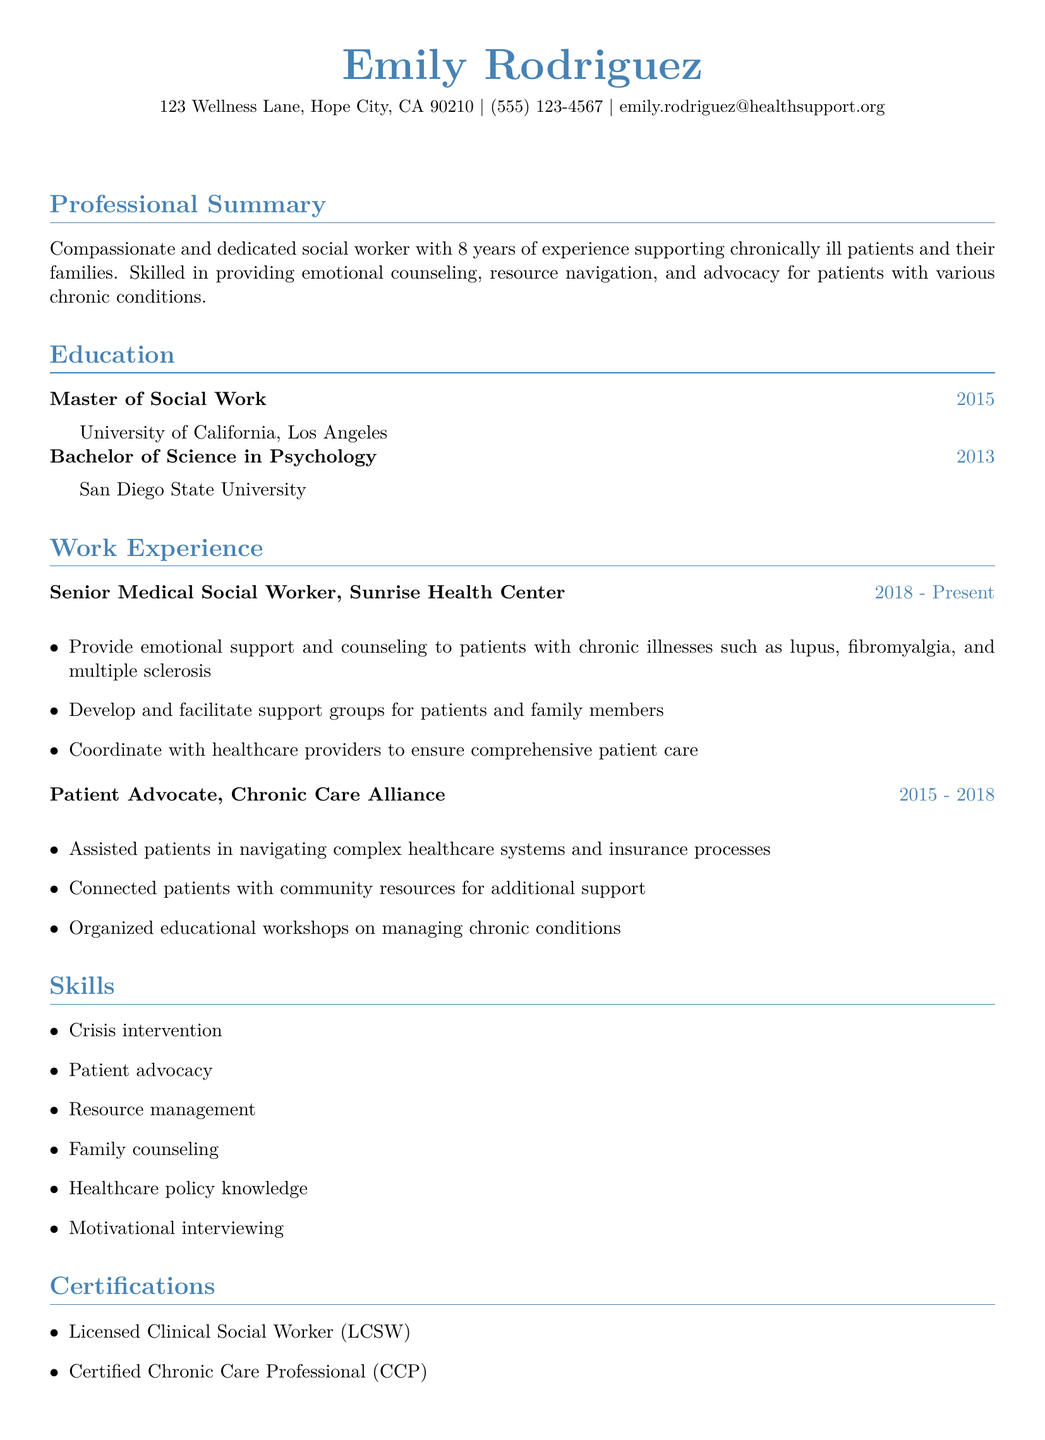what is the name of the social worker? The name at the top of the CV is Emily Rodriguez.
Answer: Emily Rodriguez how many years of experience does the social worker have? The professional summary states that she has 8 years of experience.
Answer: 8 years where did Emily obtain her Master's degree? The education section notes the Master's degree was obtained from the University of California, Los Angeles.
Answer: University of California, Los Angeles which organization did Emily work for as a Patient Advocate? The work experience section specifies that she was a Patient Advocate at Chronic Care Alliance.
Answer: Chronic Care Alliance what is one skill listed in the CV? The skills section includes several skills, one example is crisis intervention.
Answer: Crisis intervention what certification does Emily hold related to chronic care? The certifications section indicates she is a Certified Chronic Care Professional.
Answer: Certified Chronic Care Professional in which year did Emily complete her Bachelor's degree? The education section shows the Bachelor's degree was completed in 2013.
Answer: 2013 what type of social worker license does Emily have? The certifications section mentions she has a Licensed Clinical Social Worker certification.
Answer: Licensed Clinical Social Worker how many professional memberships does Emily have listed? The professional memberships section lists two organizations.
Answer: 2 